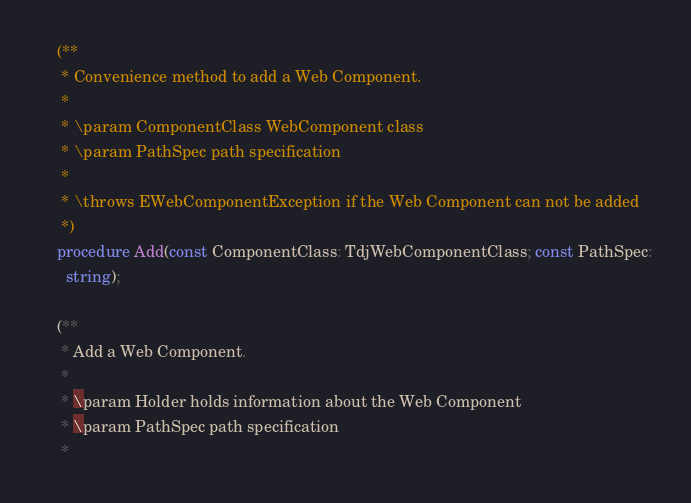<code> <loc_0><loc_0><loc_500><loc_500><_Pascal_>    (**
     * Convenience method to add a Web Component.
     *
     * \param ComponentClass WebComponent class
     * \param PathSpec path specification
     *
     * \throws EWebComponentException if the Web Component can not be added
     *)
    procedure Add(const ComponentClass: TdjWebComponentClass; const PathSpec:
      string);

    (**
     * Add a Web Component.
     *
     * \param Holder holds information about the Web Component
     * \param PathSpec path specification
     *</code> 